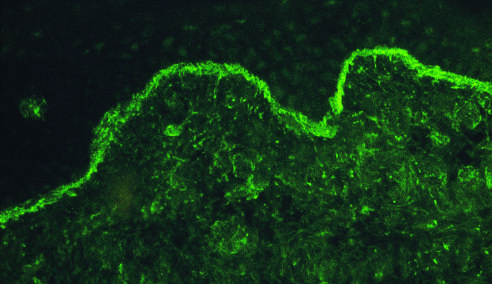does an immunofluorescence micrograph stained for igg reveal deposits of ig along the dermo-epidermal junction?
Answer the question using a single word or phrase. Yes 